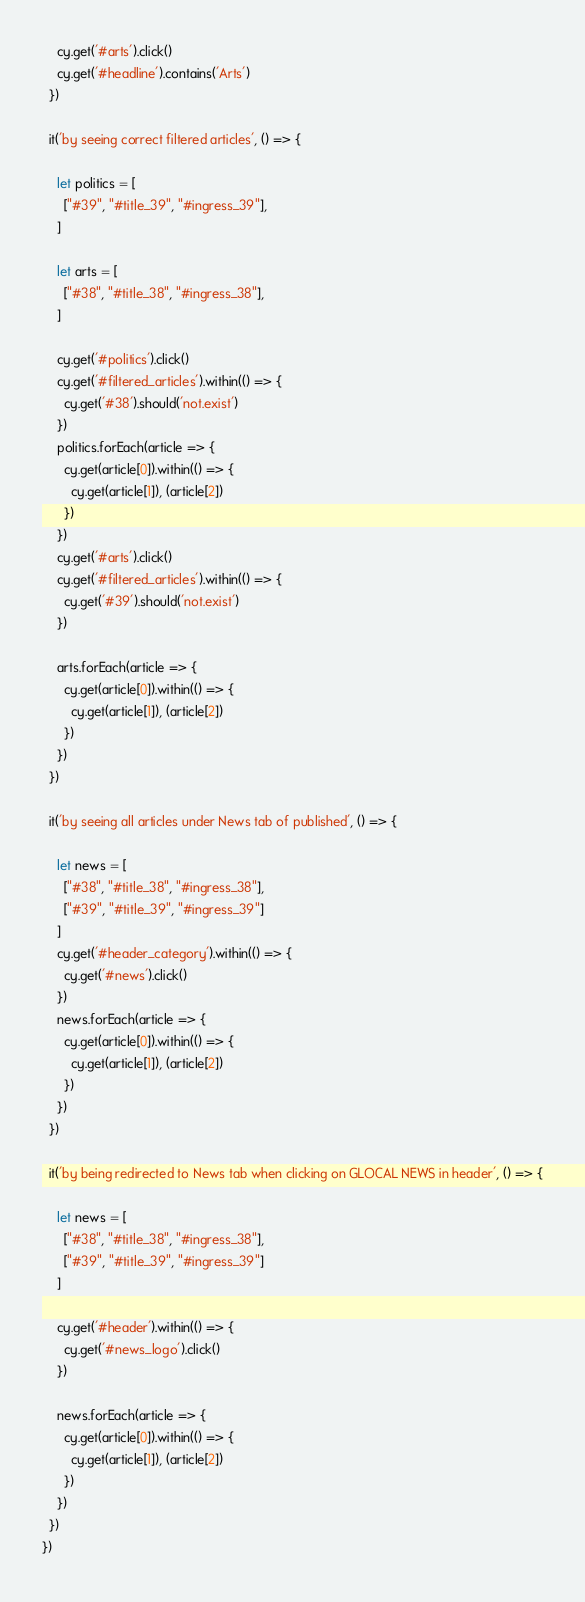Convert code to text. <code><loc_0><loc_0><loc_500><loc_500><_JavaScript_>    cy.get('#arts').click()
    cy.get('#headline').contains('Arts')
  })

  it('by seeing correct filtered articles', () => {

    let politics = [
      ["#39", "#title_39", "#ingress_39"],
    ]

    let arts = [
      ["#38", "#title_38", "#ingress_38"],
    ]

    cy.get('#politics').click()
    cy.get('#filtered_articles').within(() => {
      cy.get('#38').should('not.exist')
    })
    politics.forEach(article => {
      cy.get(article[0]).within(() => {
        cy.get(article[1]), (article[2])
      })
    })
    cy.get('#arts').click()
    cy.get('#filtered_articles').within(() => {
      cy.get('#39').should('not.exist')
    })

    arts.forEach(article => {
      cy.get(article[0]).within(() => {
        cy.get(article[1]), (article[2])
      })
    })
  })

  it('by seeing all articles under News tab of published', () => {

    let news = [
      ["#38", "#title_38", "#ingress_38"],
      ["#39", "#title_39", "#ingress_39"]
    ]
    cy.get('#header_category').within(() => {
      cy.get('#news').click()
    })
    news.forEach(article => {
      cy.get(article[0]).within(() => {
        cy.get(article[1]), (article[2])
      })
    })
  })

  it('by being redirected to News tab when clicking on GLOCAL NEWS in header', () => {

    let news = [
      ["#38", "#title_38", "#ingress_38"],
      ["#39", "#title_39", "#ingress_39"]
    ]

    cy.get('#header').within(() => {
      cy.get('#news_logo').click()
    })

    news.forEach(article => {
      cy.get(article[0]).within(() => {
        cy.get(article[1]), (article[2])
      })
    })
  })
})
</code> 